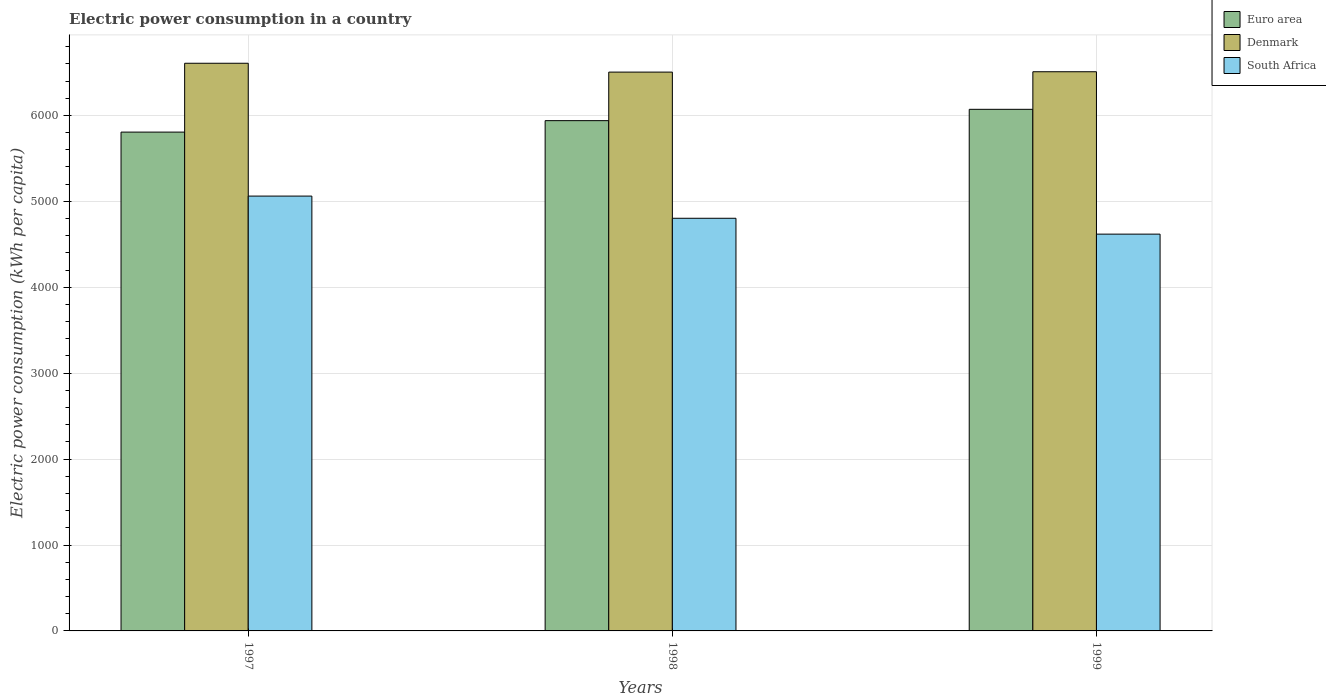Are the number of bars per tick equal to the number of legend labels?
Offer a very short reply. Yes. How many bars are there on the 1st tick from the left?
Offer a terse response. 3. How many bars are there on the 3rd tick from the right?
Offer a terse response. 3. In how many cases, is the number of bars for a given year not equal to the number of legend labels?
Your answer should be very brief. 0. What is the electric power consumption in in South Africa in 1998?
Offer a terse response. 4802.9. Across all years, what is the maximum electric power consumption in in Euro area?
Offer a very short reply. 6071.09. Across all years, what is the minimum electric power consumption in in South Africa?
Offer a very short reply. 4618.36. In which year was the electric power consumption in in Denmark maximum?
Provide a short and direct response. 1997. In which year was the electric power consumption in in South Africa minimum?
Ensure brevity in your answer.  1999. What is the total electric power consumption in in Denmark in the graph?
Your answer should be very brief. 1.96e+04. What is the difference between the electric power consumption in in Euro area in 1998 and that in 1999?
Keep it short and to the point. -131.84. What is the difference between the electric power consumption in in Denmark in 1998 and the electric power consumption in in Euro area in 1997?
Keep it short and to the point. 698.39. What is the average electric power consumption in in Euro area per year?
Provide a short and direct response. 5938.73. In the year 1999, what is the difference between the electric power consumption in in Denmark and electric power consumption in in South Africa?
Keep it short and to the point. 1890.16. In how many years, is the electric power consumption in in Denmark greater than 4000 kWh per capita?
Make the answer very short. 3. What is the ratio of the electric power consumption in in Euro area in 1997 to that in 1999?
Keep it short and to the point. 0.96. Is the difference between the electric power consumption in in Denmark in 1998 and 1999 greater than the difference between the electric power consumption in in South Africa in 1998 and 1999?
Your answer should be compact. No. What is the difference between the highest and the second highest electric power consumption in in Euro area?
Your response must be concise. 131.84. What is the difference between the highest and the lowest electric power consumption in in Euro area?
Keep it short and to the point. 265.22. Is the sum of the electric power consumption in in Euro area in 1997 and 1999 greater than the maximum electric power consumption in in South Africa across all years?
Your answer should be compact. Yes. What does the 1st bar from the right in 1999 represents?
Your answer should be compact. South Africa. Is it the case that in every year, the sum of the electric power consumption in in Euro area and electric power consumption in in Denmark is greater than the electric power consumption in in South Africa?
Make the answer very short. Yes. How many bars are there?
Provide a short and direct response. 9. How many years are there in the graph?
Your answer should be very brief. 3. What is the difference between two consecutive major ticks on the Y-axis?
Provide a short and direct response. 1000. Are the values on the major ticks of Y-axis written in scientific E-notation?
Your response must be concise. No. Does the graph contain grids?
Give a very brief answer. Yes. How are the legend labels stacked?
Provide a short and direct response. Vertical. What is the title of the graph?
Ensure brevity in your answer.  Electric power consumption in a country. Does "Latvia" appear as one of the legend labels in the graph?
Your answer should be very brief. No. What is the label or title of the X-axis?
Make the answer very short. Years. What is the label or title of the Y-axis?
Ensure brevity in your answer.  Electric power consumption (kWh per capita). What is the Electric power consumption (kWh per capita) in Euro area in 1997?
Give a very brief answer. 5805.87. What is the Electric power consumption (kWh per capita) in Denmark in 1997?
Offer a terse response. 6607.2. What is the Electric power consumption (kWh per capita) in South Africa in 1997?
Make the answer very short. 5061.2. What is the Electric power consumption (kWh per capita) in Euro area in 1998?
Offer a very short reply. 5939.25. What is the Electric power consumption (kWh per capita) of Denmark in 1998?
Your answer should be compact. 6504.26. What is the Electric power consumption (kWh per capita) of South Africa in 1998?
Your answer should be compact. 4802.9. What is the Electric power consumption (kWh per capita) in Euro area in 1999?
Provide a short and direct response. 6071.09. What is the Electric power consumption (kWh per capita) of Denmark in 1999?
Make the answer very short. 6508.51. What is the Electric power consumption (kWh per capita) of South Africa in 1999?
Ensure brevity in your answer.  4618.36. Across all years, what is the maximum Electric power consumption (kWh per capita) in Euro area?
Your response must be concise. 6071.09. Across all years, what is the maximum Electric power consumption (kWh per capita) in Denmark?
Provide a succinct answer. 6607.2. Across all years, what is the maximum Electric power consumption (kWh per capita) of South Africa?
Your answer should be compact. 5061.2. Across all years, what is the minimum Electric power consumption (kWh per capita) in Euro area?
Keep it short and to the point. 5805.87. Across all years, what is the minimum Electric power consumption (kWh per capita) in Denmark?
Offer a terse response. 6504.26. Across all years, what is the minimum Electric power consumption (kWh per capita) in South Africa?
Your answer should be very brief. 4618.36. What is the total Electric power consumption (kWh per capita) in Euro area in the graph?
Make the answer very short. 1.78e+04. What is the total Electric power consumption (kWh per capita) in Denmark in the graph?
Your answer should be very brief. 1.96e+04. What is the total Electric power consumption (kWh per capita) of South Africa in the graph?
Your response must be concise. 1.45e+04. What is the difference between the Electric power consumption (kWh per capita) in Euro area in 1997 and that in 1998?
Your answer should be very brief. -133.38. What is the difference between the Electric power consumption (kWh per capita) of Denmark in 1997 and that in 1998?
Make the answer very short. 102.95. What is the difference between the Electric power consumption (kWh per capita) in South Africa in 1997 and that in 1998?
Keep it short and to the point. 258.3. What is the difference between the Electric power consumption (kWh per capita) in Euro area in 1997 and that in 1999?
Provide a succinct answer. -265.22. What is the difference between the Electric power consumption (kWh per capita) of Denmark in 1997 and that in 1999?
Your answer should be compact. 98.69. What is the difference between the Electric power consumption (kWh per capita) of South Africa in 1997 and that in 1999?
Ensure brevity in your answer.  442.84. What is the difference between the Electric power consumption (kWh per capita) in Euro area in 1998 and that in 1999?
Your answer should be compact. -131.84. What is the difference between the Electric power consumption (kWh per capita) of Denmark in 1998 and that in 1999?
Give a very brief answer. -4.26. What is the difference between the Electric power consumption (kWh per capita) of South Africa in 1998 and that in 1999?
Ensure brevity in your answer.  184.54. What is the difference between the Electric power consumption (kWh per capita) in Euro area in 1997 and the Electric power consumption (kWh per capita) in Denmark in 1998?
Keep it short and to the point. -698.39. What is the difference between the Electric power consumption (kWh per capita) of Euro area in 1997 and the Electric power consumption (kWh per capita) of South Africa in 1998?
Make the answer very short. 1002.97. What is the difference between the Electric power consumption (kWh per capita) in Denmark in 1997 and the Electric power consumption (kWh per capita) in South Africa in 1998?
Provide a succinct answer. 1804.3. What is the difference between the Electric power consumption (kWh per capita) of Euro area in 1997 and the Electric power consumption (kWh per capita) of Denmark in 1999?
Provide a succinct answer. -702.65. What is the difference between the Electric power consumption (kWh per capita) of Euro area in 1997 and the Electric power consumption (kWh per capita) of South Africa in 1999?
Offer a very short reply. 1187.51. What is the difference between the Electric power consumption (kWh per capita) in Denmark in 1997 and the Electric power consumption (kWh per capita) in South Africa in 1999?
Give a very brief answer. 1988.84. What is the difference between the Electric power consumption (kWh per capita) of Euro area in 1998 and the Electric power consumption (kWh per capita) of Denmark in 1999?
Provide a short and direct response. -569.27. What is the difference between the Electric power consumption (kWh per capita) of Euro area in 1998 and the Electric power consumption (kWh per capita) of South Africa in 1999?
Your answer should be very brief. 1320.89. What is the difference between the Electric power consumption (kWh per capita) in Denmark in 1998 and the Electric power consumption (kWh per capita) in South Africa in 1999?
Keep it short and to the point. 1885.9. What is the average Electric power consumption (kWh per capita) in Euro area per year?
Your response must be concise. 5938.73. What is the average Electric power consumption (kWh per capita) of Denmark per year?
Provide a short and direct response. 6539.99. What is the average Electric power consumption (kWh per capita) of South Africa per year?
Make the answer very short. 4827.49. In the year 1997, what is the difference between the Electric power consumption (kWh per capita) of Euro area and Electric power consumption (kWh per capita) of Denmark?
Offer a very short reply. -801.34. In the year 1997, what is the difference between the Electric power consumption (kWh per capita) of Euro area and Electric power consumption (kWh per capita) of South Africa?
Keep it short and to the point. 744.67. In the year 1997, what is the difference between the Electric power consumption (kWh per capita) of Denmark and Electric power consumption (kWh per capita) of South Africa?
Your response must be concise. 1546. In the year 1998, what is the difference between the Electric power consumption (kWh per capita) of Euro area and Electric power consumption (kWh per capita) of Denmark?
Offer a very short reply. -565.01. In the year 1998, what is the difference between the Electric power consumption (kWh per capita) in Euro area and Electric power consumption (kWh per capita) in South Africa?
Your response must be concise. 1136.35. In the year 1998, what is the difference between the Electric power consumption (kWh per capita) in Denmark and Electric power consumption (kWh per capita) in South Africa?
Your answer should be compact. 1701.36. In the year 1999, what is the difference between the Electric power consumption (kWh per capita) of Euro area and Electric power consumption (kWh per capita) of Denmark?
Provide a short and direct response. -437.43. In the year 1999, what is the difference between the Electric power consumption (kWh per capita) of Euro area and Electric power consumption (kWh per capita) of South Africa?
Offer a very short reply. 1452.73. In the year 1999, what is the difference between the Electric power consumption (kWh per capita) in Denmark and Electric power consumption (kWh per capita) in South Africa?
Give a very brief answer. 1890.16. What is the ratio of the Electric power consumption (kWh per capita) of Euro area in 1997 to that in 1998?
Offer a very short reply. 0.98. What is the ratio of the Electric power consumption (kWh per capita) of Denmark in 1997 to that in 1998?
Your answer should be compact. 1.02. What is the ratio of the Electric power consumption (kWh per capita) in South Africa in 1997 to that in 1998?
Make the answer very short. 1.05. What is the ratio of the Electric power consumption (kWh per capita) of Euro area in 1997 to that in 1999?
Provide a short and direct response. 0.96. What is the ratio of the Electric power consumption (kWh per capita) in Denmark in 1997 to that in 1999?
Give a very brief answer. 1.02. What is the ratio of the Electric power consumption (kWh per capita) in South Africa in 1997 to that in 1999?
Your answer should be very brief. 1.1. What is the ratio of the Electric power consumption (kWh per capita) of Euro area in 1998 to that in 1999?
Provide a succinct answer. 0.98. What is the difference between the highest and the second highest Electric power consumption (kWh per capita) in Euro area?
Make the answer very short. 131.84. What is the difference between the highest and the second highest Electric power consumption (kWh per capita) of Denmark?
Offer a very short reply. 98.69. What is the difference between the highest and the second highest Electric power consumption (kWh per capita) of South Africa?
Your response must be concise. 258.3. What is the difference between the highest and the lowest Electric power consumption (kWh per capita) of Euro area?
Provide a short and direct response. 265.22. What is the difference between the highest and the lowest Electric power consumption (kWh per capita) of Denmark?
Offer a very short reply. 102.95. What is the difference between the highest and the lowest Electric power consumption (kWh per capita) in South Africa?
Offer a very short reply. 442.84. 